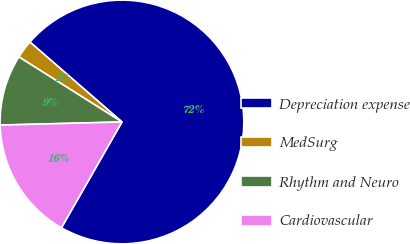Convert chart to OTSL. <chart><loc_0><loc_0><loc_500><loc_500><pie_chart><fcel>Depreciation expense<fcel>MedSurg<fcel>Rhythm and Neuro<fcel>Cardiovascular<nl><fcel>71.89%<fcel>2.42%<fcel>9.37%<fcel>16.32%<nl></chart> 